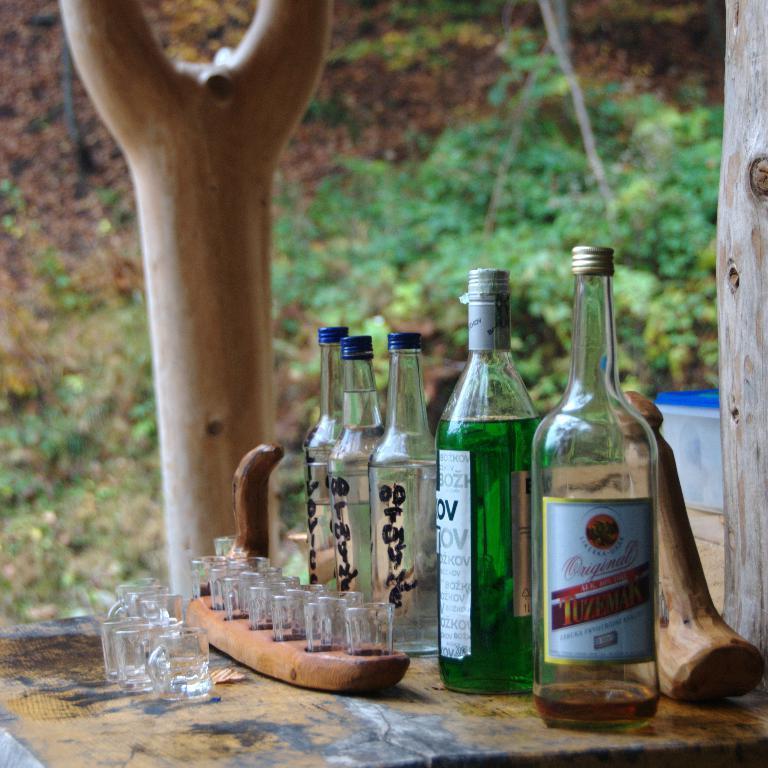Describe this image in one or two sentences. In this picture there are five bottles on a wooden table. There are few glasses on a wooden tray. some trees in the background. 